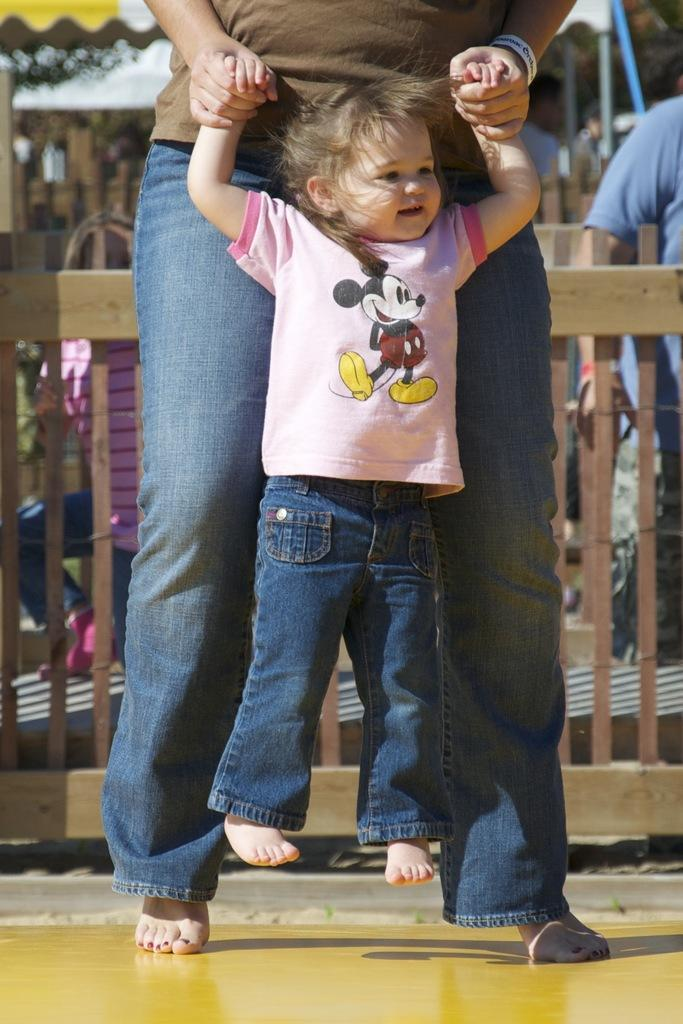Who is the main subject in the image? There is a girl in the middle of the image. Is there anyone else in the image? Yes, there is a person holding the girl. What can be seen in the background of the image? There is a wooden railing in the background of the image. What type of lunch is being served to the committee in the image? There is no mention of a lunch or committee in the image; it features a girl and a person holding her with a wooden railing in the background. 